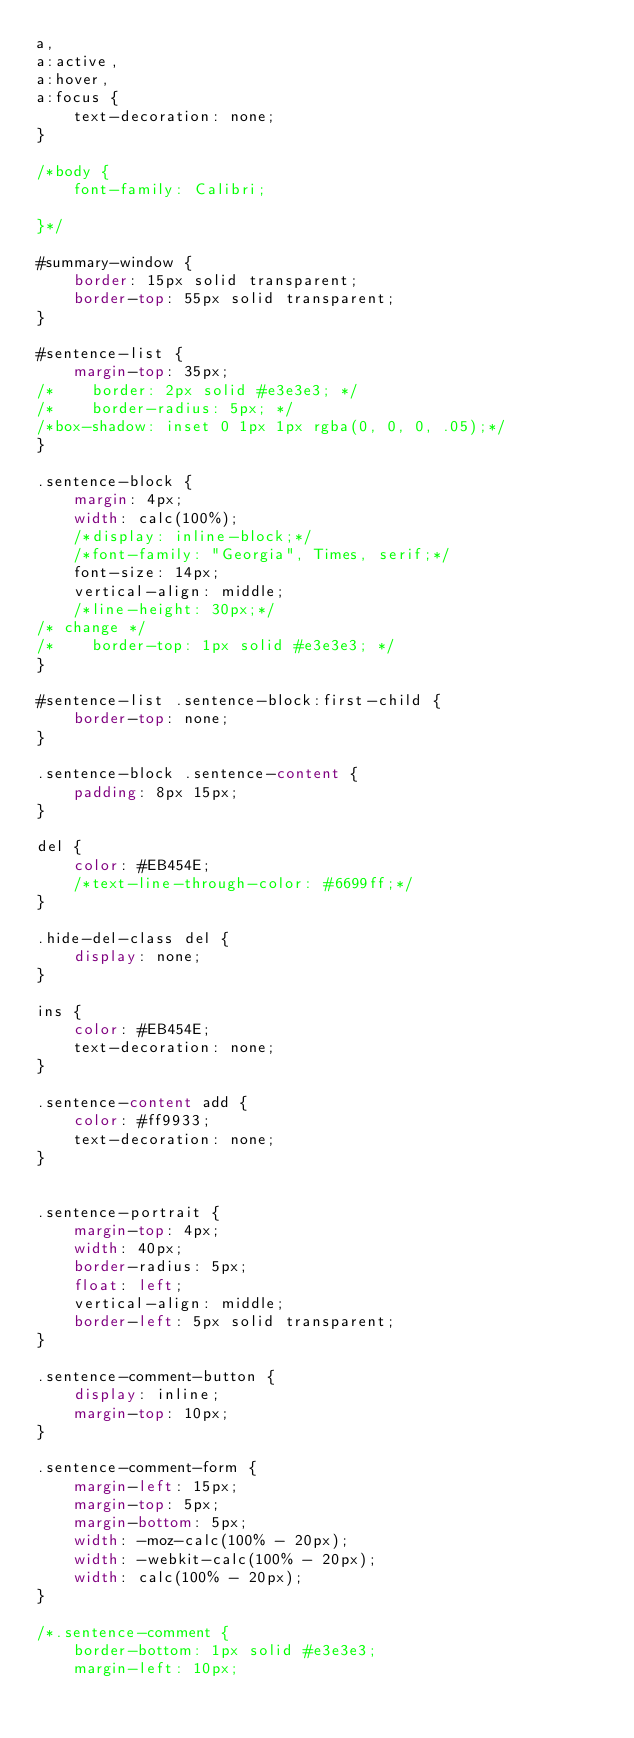<code> <loc_0><loc_0><loc_500><loc_500><_CSS_>a,
a:active,
a:hover,
a:focus {
    text-decoration: none;
}

/*body {
    font-family: Calibri;

}*/

#summary-window {
    border: 15px solid transparent;
    border-top: 55px solid transparent;
}

#sentence-list {
    margin-top: 35px;
/*    border: 2px solid #e3e3e3; */
/*    border-radius: 5px; */
/*box-shadow: inset 0 1px 1px rgba(0, 0, 0, .05);*/
}

.sentence-block {
    margin: 4px;
    width: calc(100%);
    /*display: inline-block;*/
    /*font-family: "Georgia", Times, serif;*/
    font-size: 14px;
    vertical-align: middle;
    /*line-height: 30px;*/
/* change */
/*    border-top: 1px solid #e3e3e3; */
}

#sentence-list .sentence-block:first-child {
    border-top: none;
}

.sentence-block .sentence-content {
    padding: 8px 15px;
}

del {
    color: #EB454E;
    /*text-line-through-color: #6699ff;*/
}

.hide-del-class del {
    display: none;
}

ins {
    color: #EB454E;
    text-decoration: none;
}

.sentence-content add {
    color: #ff9933;
    text-decoration: none;
}


.sentence-portrait {
    margin-top: 4px;
    width: 40px;
    border-radius: 5px;
    float: left;
    vertical-align: middle;
    border-left: 5px solid transparent;
}

.sentence-comment-button {
    display: inline;
    margin-top: 10px;
}

.sentence-comment-form {
    margin-left: 15px;
    margin-top: 5px;
    margin-bottom: 5px;
    width: -moz-calc(100% - 20px);
    width: -webkit-calc(100% - 20px);
    width: calc(100% - 20px);
}

/*.sentence-comment {
    border-bottom: 1px solid #e3e3e3;
    margin-left: 10px;</code> 